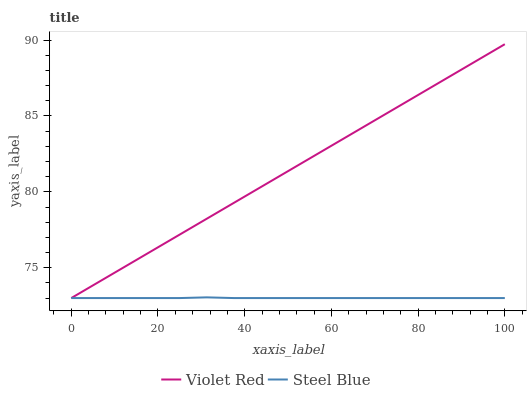Does Steel Blue have the minimum area under the curve?
Answer yes or no. Yes. Does Violet Red have the maximum area under the curve?
Answer yes or no. Yes. Does Steel Blue have the maximum area under the curve?
Answer yes or no. No. Is Violet Red the smoothest?
Answer yes or no. Yes. Is Steel Blue the roughest?
Answer yes or no. Yes. Is Steel Blue the smoothest?
Answer yes or no. No. Does Violet Red have the lowest value?
Answer yes or no. Yes. Does Violet Red have the highest value?
Answer yes or no. Yes. Does Steel Blue have the highest value?
Answer yes or no. No. Does Violet Red intersect Steel Blue?
Answer yes or no. Yes. Is Violet Red less than Steel Blue?
Answer yes or no. No. Is Violet Red greater than Steel Blue?
Answer yes or no. No. 